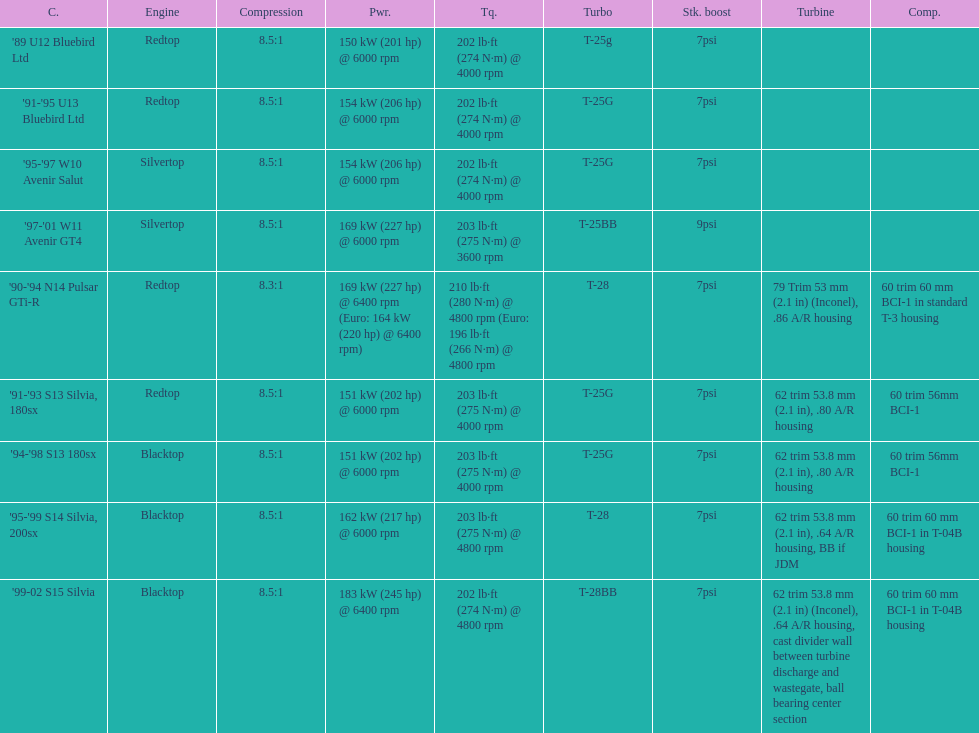What is his/her compression ratio for the 90-94 n14 pulsar gti-r? 8.3:1. 